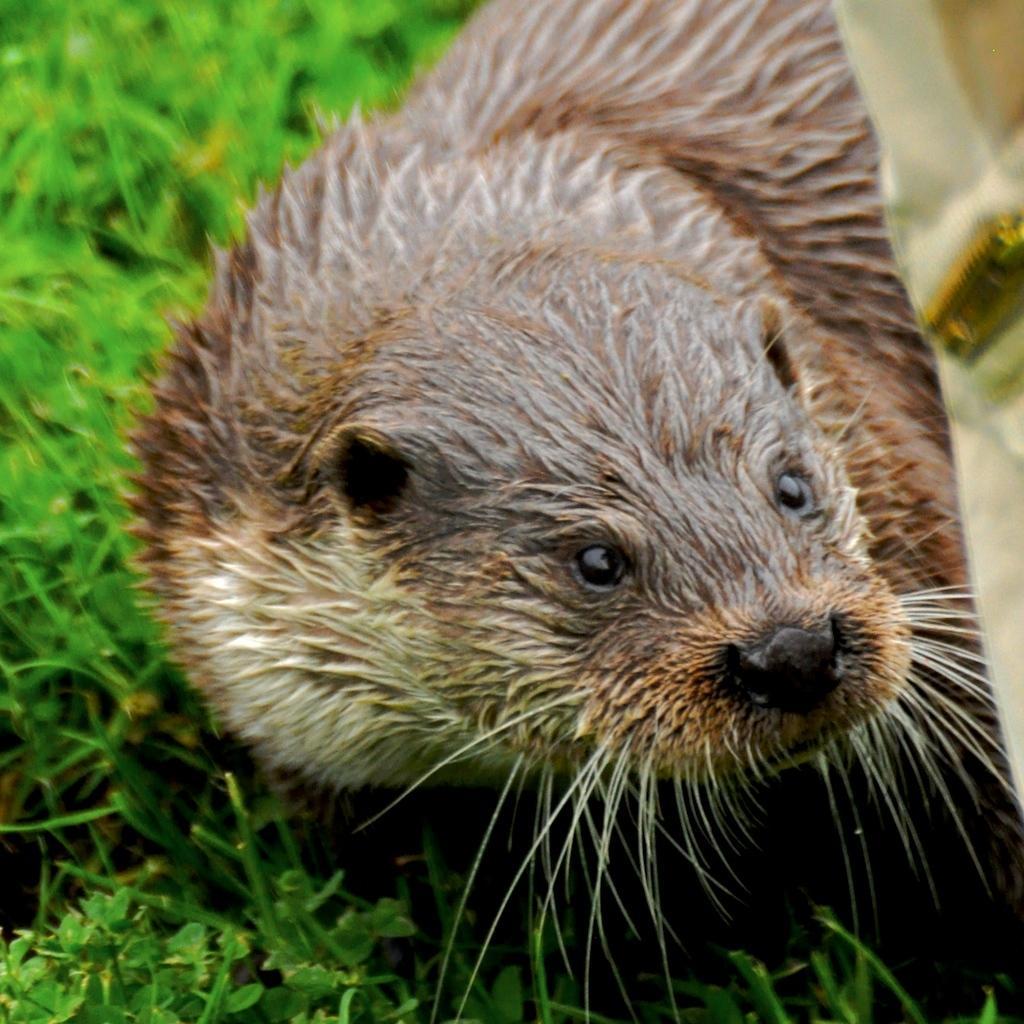How would you summarize this image in a sentence or two? This image consists of an otter in brown color. At the bottom, there is green grass. 